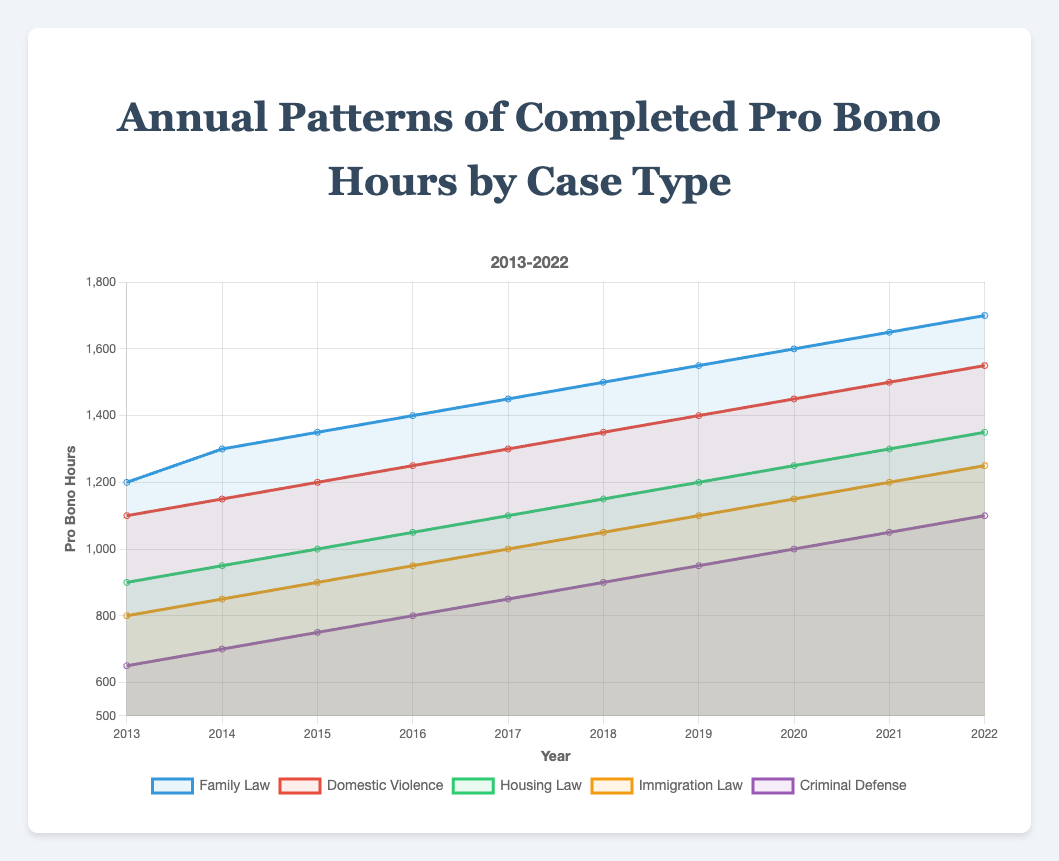What is the total number of pro bono hours completed in Family Law over the last decade? Add the Family Law hours from 2013 to 2022: 1200 + 1300 + 1350 + 1400 + 1450 + 1500 + 1550 + 1600 + 1650 + 1700
Answer: 14700 In which year did Domestic Violence cases see the highest number of pro bono hours completed? Look for the highest value in the Domestic Violence dataset, which is 1550 in the year 2022
Answer: 2022 What is the average number of pro bono hours completed in Housing Law between 2015 and 2018? Sum the Housing Law hours from 2015 to 2018 and divide by the number of years: (1000 + 1050 + 1100 + 1150) / 4 = 4300 / 4
Answer: 1075 How much did the pro bono hours for Immigration Law increase from 2013 to 2022? Subtract the 2013 value from the 2022 value: 1250 - 800
Answer: 450 Between which consecutive years did Criminal Defense see the largest increase in pro bono hours? Compare the year-over-year increases in the Criminal Defense dataset: 700-650, 750-700, 800-750, 850-800, 900-850, 950-900, 1000-950, 1050-1000, 1100-1050. The largest increase is between 2019 and 2020 (1000 - 950 = 50)
Answer: 2019 to 2020 Which case type had the least number of pro bono hours completed in 2016? Compare the 2016 values for all case types: Family Law (1400), Domestic Violence (1250), Housing Law (1050), Immigration Law (950), Criminal Defense (800). The least value is in Criminal Defense
Answer: Criminal Defense How does the trend in Family Law pro bono hours compare to Domestic Violence from 2013 to 2022? Both trends increase over time. Compare the starting and ending values: Family Law (1200 to 1700), Domestic Violence (1100 to 1550). Family Law consistently has higher values and shows a slightly steeper increase
Answer: Family Law shows a steeper increase What's the difference in pro bono hours between Housing Law and Immigration Law in 2020? Subtract the Immigration Law hours from the Housing Law hours for 2020: 1250 - 1150
Answer: 100 Which case type demonstrated a steady increase of at least 50 hours each year? Evaluate the year-over-year increases for each case type. Family Law increases by at least 50 hours each year
Answer: Family Law Which year shows the highest combined total number of pro bono hours across all case types? Sum the pro bono hours across all case types for each year and find the maximum sum: 
2013 (4650), 2014 (4950), 2015 (5250), 2016 (5450), 2017 (5700), 2018 (5950), 2019 (6200), 2020 (6450), 2021 (6700), 2022 (6950). The highest total is in 2022
Answer: 2022 